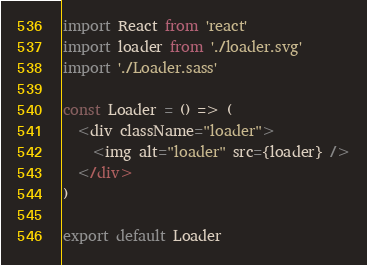<code> <loc_0><loc_0><loc_500><loc_500><_JavaScript_>import React from 'react'
import loader from './loader.svg'
import './Loader.sass'

const Loader = () => (
  <div className="loader">
    <img alt="loader" src={loader} />
  </div>
)

export default Loader
</code> 